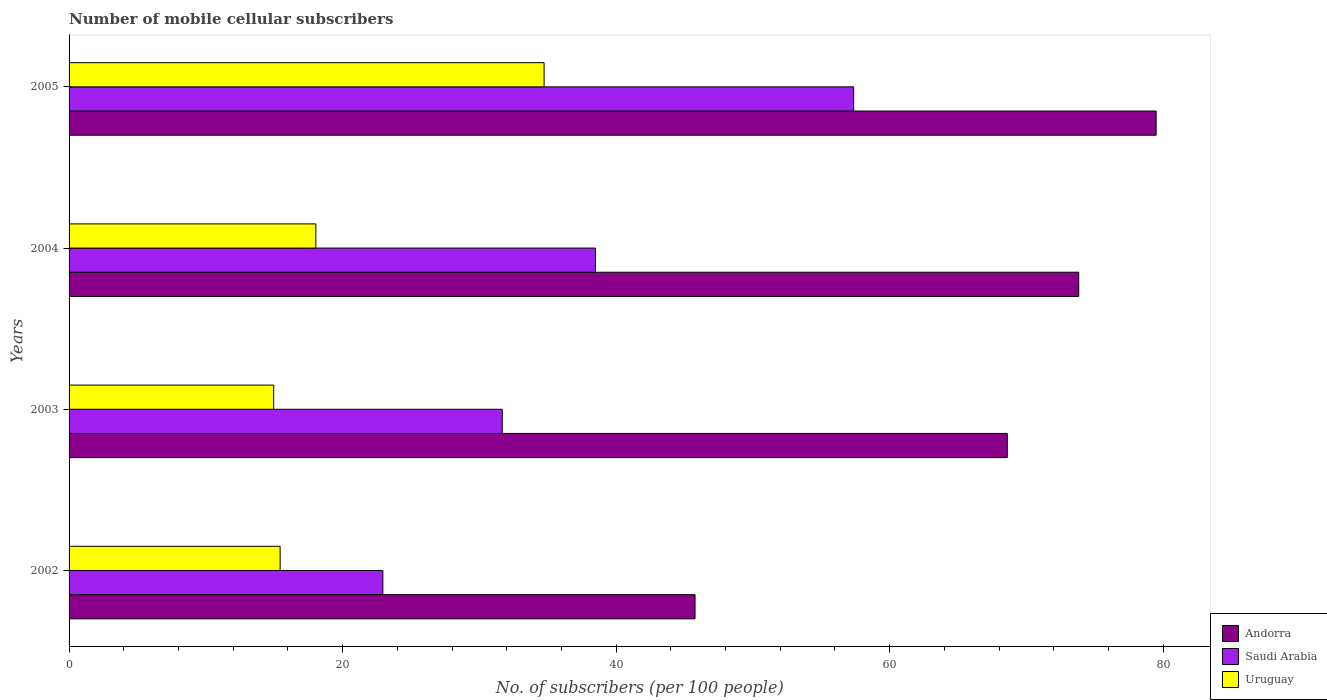How many groups of bars are there?
Ensure brevity in your answer.  4. How many bars are there on the 2nd tick from the top?
Your answer should be compact. 3. What is the label of the 3rd group of bars from the top?
Make the answer very short. 2003. What is the number of mobile cellular subscribers in Andorra in 2004?
Your response must be concise. 73.82. Across all years, what is the maximum number of mobile cellular subscribers in Andorra?
Make the answer very short. 79.48. Across all years, what is the minimum number of mobile cellular subscribers in Andorra?
Provide a succinct answer. 45.77. In which year was the number of mobile cellular subscribers in Uruguay maximum?
Provide a short and direct response. 2005. What is the total number of mobile cellular subscribers in Andorra in the graph?
Offer a terse response. 267.68. What is the difference between the number of mobile cellular subscribers in Uruguay in 2004 and that in 2005?
Your response must be concise. -16.69. What is the difference between the number of mobile cellular subscribers in Saudi Arabia in 2005 and the number of mobile cellular subscribers in Uruguay in 2002?
Offer a terse response. 41.94. What is the average number of mobile cellular subscribers in Andorra per year?
Give a very brief answer. 66.92. In the year 2002, what is the difference between the number of mobile cellular subscribers in Saudi Arabia and number of mobile cellular subscribers in Andorra?
Make the answer very short. -22.83. What is the ratio of the number of mobile cellular subscribers in Uruguay in 2002 to that in 2003?
Offer a very short reply. 1.03. Is the difference between the number of mobile cellular subscribers in Saudi Arabia in 2004 and 2005 greater than the difference between the number of mobile cellular subscribers in Andorra in 2004 and 2005?
Provide a short and direct response. No. What is the difference between the highest and the second highest number of mobile cellular subscribers in Andorra?
Provide a succinct answer. 5.66. What is the difference between the highest and the lowest number of mobile cellular subscribers in Andorra?
Provide a succinct answer. 33.71. Is the sum of the number of mobile cellular subscribers in Uruguay in 2002 and 2003 greater than the maximum number of mobile cellular subscribers in Andorra across all years?
Keep it short and to the point. No. What does the 2nd bar from the top in 2004 represents?
Provide a succinct answer. Saudi Arabia. What does the 2nd bar from the bottom in 2003 represents?
Your answer should be very brief. Saudi Arabia. How many bars are there?
Give a very brief answer. 12. What is the difference between two consecutive major ticks on the X-axis?
Offer a terse response. 20. Does the graph contain grids?
Offer a terse response. No. How are the legend labels stacked?
Make the answer very short. Vertical. What is the title of the graph?
Provide a succinct answer. Number of mobile cellular subscribers. What is the label or title of the X-axis?
Ensure brevity in your answer.  No. of subscribers (per 100 people). What is the No. of subscribers (per 100 people) of Andorra in 2002?
Offer a very short reply. 45.77. What is the No. of subscribers (per 100 people) in Saudi Arabia in 2002?
Provide a succinct answer. 22.95. What is the No. of subscribers (per 100 people) of Uruguay in 2002?
Your answer should be very brief. 15.43. What is the No. of subscribers (per 100 people) in Andorra in 2003?
Provide a short and direct response. 68.6. What is the No. of subscribers (per 100 people) in Saudi Arabia in 2003?
Give a very brief answer. 31.67. What is the No. of subscribers (per 100 people) of Uruguay in 2003?
Give a very brief answer. 14.96. What is the No. of subscribers (per 100 people) of Andorra in 2004?
Your response must be concise. 73.82. What is the No. of subscribers (per 100 people) in Saudi Arabia in 2004?
Offer a very short reply. 38.49. What is the No. of subscribers (per 100 people) of Uruguay in 2004?
Provide a succinct answer. 18.04. What is the No. of subscribers (per 100 people) in Andorra in 2005?
Your answer should be very brief. 79.48. What is the No. of subscribers (per 100 people) of Saudi Arabia in 2005?
Your response must be concise. 57.37. What is the No. of subscribers (per 100 people) of Uruguay in 2005?
Offer a terse response. 34.73. Across all years, what is the maximum No. of subscribers (per 100 people) in Andorra?
Keep it short and to the point. 79.48. Across all years, what is the maximum No. of subscribers (per 100 people) of Saudi Arabia?
Provide a succinct answer. 57.37. Across all years, what is the maximum No. of subscribers (per 100 people) in Uruguay?
Offer a terse response. 34.73. Across all years, what is the minimum No. of subscribers (per 100 people) in Andorra?
Your answer should be compact. 45.77. Across all years, what is the minimum No. of subscribers (per 100 people) of Saudi Arabia?
Provide a succinct answer. 22.95. Across all years, what is the minimum No. of subscribers (per 100 people) of Uruguay?
Your answer should be very brief. 14.96. What is the total No. of subscribers (per 100 people) in Andorra in the graph?
Your answer should be compact. 267.68. What is the total No. of subscribers (per 100 people) in Saudi Arabia in the graph?
Make the answer very short. 150.48. What is the total No. of subscribers (per 100 people) of Uruguay in the graph?
Keep it short and to the point. 83.17. What is the difference between the No. of subscribers (per 100 people) of Andorra in 2002 and that in 2003?
Ensure brevity in your answer.  -22.83. What is the difference between the No. of subscribers (per 100 people) in Saudi Arabia in 2002 and that in 2003?
Your answer should be compact. -8.73. What is the difference between the No. of subscribers (per 100 people) in Uruguay in 2002 and that in 2003?
Your answer should be compact. 0.47. What is the difference between the No. of subscribers (per 100 people) of Andorra in 2002 and that in 2004?
Give a very brief answer. -28.05. What is the difference between the No. of subscribers (per 100 people) of Saudi Arabia in 2002 and that in 2004?
Provide a succinct answer. -15.54. What is the difference between the No. of subscribers (per 100 people) of Uruguay in 2002 and that in 2004?
Give a very brief answer. -2.61. What is the difference between the No. of subscribers (per 100 people) of Andorra in 2002 and that in 2005?
Give a very brief answer. -33.71. What is the difference between the No. of subscribers (per 100 people) in Saudi Arabia in 2002 and that in 2005?
Offer a terse response. -34.42. What is the difference between the No. of subscribers (per 100 people) in Uruguay in 2002 and that in 2005?
Provide a short and direct response. -19.3. What is the difference between the No. of subscribers (per 100 people) in Andorra in 2003 and that in 2004?
Provide a short and direct response. -5.22. What is the difference between the No. of subscribers (per 100 people) in Saudi Arabia in 2003 and that in 2004?
Offer a very short reply. -6.82. What is the difference between the No. of subscribers (per 100 people) of Uruguay in 2003 and that in 2004?
Your answer should be compact. -3.08. What is the difference between the No. of subscribers (per 100 people) of Andorra in 2003 and that in 2005?
Make the answer very short. -10.88. What is the difference between the No. of subscribers (per 100 people) of Saudi Arabia in 2003 and that in 2005?
Your answer should be very brief. -25.69. What is the difference between the No. of subscribers (per 100 people) in Uruguay in 2003 and that in 2005?
Make the answer very short. -19.77. What is the difference between the No. of subscribers (per 100 people) in Andorra in 2004 and that in 2005?
Keep it short and to the point. -5.66. What is the difference between the No. of subscribers (per 100 people) of Saudi Arabia in 2004 and that in 2005?
Your answer should be very brief. -18.88. What is the difference between the No. of subscribers (per 100 people) in Uruguay in 2004 and that in 2005?
Provide a succinct answer. -16.69. What is the difference between the No. of subscribers (per 100 people) of Andorra in 2002 and the No. of subscribers (per 100 people) of Saudi Arabia in 2003?
Provide a succinct answer. 14.1. What is the difference between the No. of subscribers (per 100 people) of Andorra in 2002 and the No. of subscribers (per 100 people) of Uruguay in 2003?
Offer a very short reply. 30.81. What is the difference between the No. of subscribers (per 100 people) in Saudi Arabia in 2002 and the No. of subscribers (per 100 people) in Uruguay in 2003?
Your answer should be very brief. 7.98. What is the difference between the No. of subscribers (per 100 people) of Andorra in 2002 and the No. of subscribers (per 100 people) of Saudi Arabia in 2004?
Provide a succinct answer. 7.28. What is the difference between the No. of subscribers (per 100 people) of Andorra in 2002 and the No. of subscribers (per 100 people) of Uruguay in 2004?
Offer a very short reply. 27.73. What is the difference between the No. of subscribers (per 100 people) in Saudi Arabia in 2002 and the No. of subscribers (per 100 people) in Uruguay in 2004?
Your answer should be very brief. 4.9. What is the difference between the No. of subscribers (per 100 people) in Andorra in 2002 and the No. of subscribers (per 100 people) in Saudi Arabia in 2005?
Your response must be concise. -11.6. What is the difference between the No. of subscribers (per 100 people) of Andorra in 2002 and the No. of subscribers (per 100 people) of Uruguay in 2005?
Keep it short and to the point. 11.04. What is the difference between the No. of subscribers (per 100 people) of Saudi Arabia in 2002 and the No. of subscribers (per 100 people) of Uruguay in 2005?
Make the answer very short. -11.79. What is the difference between the No. of subscribers (per 100 people) in Andorra in 2003 and the No. of subscribers (per 100 people) in Saudi Arabia in 2004?
Make the answer very short. 30.11. What is the difference between the No. of subscribers (per 100 people) of Andorra in 2003 and the No. of subscribers (per 100 people) of Uruguay in 2004?
Provide a succinct answer. 50.56. What is the difference between the No. of subscribers (per 100 people) in Saudi Arabia in 2003 and the No. of subscribers (per 100 people) in Uruguay in 2004?
Your answer should be compact. 13.63. What is the difference between the No. of subscribers (per 100 people) of Andorra in 2003 and the No. of subscribers (per 100 people) of Saudi Arabia in 2005?
Ensure brevity in your answer.  11.23. What is the difference between the No. of subscribers (per 100 people) in Andorra in 2003 and the No. of subscribers (per 100 people) in Uruguay in 2005?
Your answer should be compact. 33.87. What is the difference between the No. of subscribers (per 100 people) of Saudi Arabia in 2003 and the No. of subscribers (per 100 people) of Uruguay in 2005?
Your answer should be very brief. -3.06. What is the difference between the No. of subscribers (per 100 people) in Andorra in 2004 and the No. of subscribers (per 100 people) in Saudi Arabia in 2005?
Give a very brief answer. 16.46. What is the difference between the No. of subscribers (per 100 people) in Andorra in 2004 and the No. of subscribers (per 100 people) in Uruguay in 2005?
Your answer should be compact. 39.09. What is the difference between the No. of subscribers (per 100 people) of Saudi Arabia in 2004 and the No. of subscribers (per 100 people) of Uruguay in 2005?
Your answer should be very brief. 3.76. What is the average No. of subscribers (per 100 people) of Andorra per year?
Provide a short and direct response. 66.92. What is the average No. of subscribers (per 100 people) of Saudi Arabia per year?
Offer a very short reply. 37.62. What is the average No. of subscribers (per 100 people) of Uruguay per year?
Ensure brevity in your answer.  20.79. In the year 2002, what is the difference between the No. of subscribers (per 100 people) of Andorra and No. of subscribers (per 100 people) of Saudi Arabia?
Give a very brief answer. 22.83. In the year 2002, what is the difference between the No. of subscribers (per 100 people) of Andorra and No. of subscribers (per 100 people) of Uruguay?
Offer a very short reply. 30.34. In the year 2002, what is the difference between the No. of subscribers (per 100 people) in Saudi Arabia and No. of subscribers (per 100 people) in Uruguay?
Provide a short and direct response. 7.51. In the year 2003, what is the difference between the No. of subscribers (per 100 people) in Andorra and No. of subscribers (per 100 people) in Saudi Arabia?
Your answer should be compact. 36.93. In the year 2003, what is the difference between the No. of subscribers (per 100 people) of Andorra and No. of subscribers (per 100 people) of Uruguay?
Make the answer very short. 53.64. In the year 2003, what is the difference between the No. of subscribers (per 100 people) of Saudi Arabia and No. of subscribers (per 100 people) of Uruguay?
Provide a short and direct response. 16.71. In the year 2004, what is the difference between the No. of subscribers (per 100 people) of Andorra and No. of subscribers (per 100 people) of Saudi Arabia?
Keep it short and to the point. 35.33. In the year 2004, what is the difference between the No. of subscribers (per 100 people) in Andorra and No. of subscribers (per 100 people) in Uruguay?
Make the answer very short. 55.78. In the year 2004, what is the difference between the No. of subscribers (per 100 people) of Saudi Arabia and No. of subscribers (per 100 people) of Uruguay?
Keep it short and to the point. 20.45. In the year 2005, what is the difference between the No. of subscribers (per 100 people) in Andorra and No. of subscribers (per 100 people) in Saudi Arabia?
Your response must be concise. 22.12. In the year 2005, what is the difference between the No. of subscribers (per 100 people) of Andorra and No. of subscribers (per 100 people) of Uruguay?
Keep it short and to the point. 44.75. In the year 2005, what is the difference between the No. of subscribers (per 100 people) in Saudi Arabia and No. of subscribers (per 100 people) in Uruguay?
Keep it short and to the point. 22.64. What is the ratio of the No. of subscribers (per 100 people) of Andorra in 2002 to that in 2003?
Ensure brevity in your answer.  0.67. What is the ratio of the No. of subscribers (per 100 people) in Saudi Arabia in 2002 to that in 2003?
Provide a short and direct response. 0.72. What is the ratio of the No. of subscribers (per 100 people) in Uruguay in 2002 to that in 2003?
Give a very brief answer. 1.03. What is the ratio of the No. of subscribers (per 100 people) of Andorra in 2002 to that in 2004?
Provide a succinct answer. 0.62. What is the ratio of the No. of subscribers (per 100 people) in Saudi Arabia in 2002 to that in 2004?
Ensure brevity in your answer.  0.6. What is the ratio of the No. of subscribers (per 100 people) of Uruguay in 2002 to that in 2004?
Make the answer very short. 0.86. What is the ratio of the No. of subscribers (per 100 people) in Andorra in 2002 to that in 2005?
Your answer should be compact. 0.58. What is the ratio of the No. of subscribers (per 100 people) of Uruguay in 2002 to that in 2005?
Ensure brevity in your answer.  0.44. What is the ratio of the No. of subscribers (per 100 people) of Andorra in 2003 to that in 2004?
Make the answer very short. 0.93. What is the ratio of the No. of subscribers (per 100 people) of Saudi Arabia in 2003 to that in 2004?
Offer a terse response. 0.82. What is the ratio of the No. of subscribers (per 100 people) in Uruguay in 2003 to that in 2004?
Offer a terse response. 0.83. What is the ratio of the No. of subscribers (per 100 people) of Andorra in 2003 to that in 2005?
Provide a short and direct response. 0.86. What is the ratio of the No. of subscribers (per 100 people) of Saudi Arabia in 2003 to that in 2005?
Your answer should be compact. 0.55. What is the ratio of the No. of subscribers (per 100 people) of Uruguay in 2003 to that in 2005?
Keep it short and to the point. 0.43. What is the ratio of the No. of subscribers (per 100 people) in Andorra in 2004 to that in 2005?
Provide a succinct answer. 0.93. What is the ratio of the No. of subscribers (per 100 people) in Saudi Arabia in 2004 to that in 2005?
Keep it short and to the point. 0.67. What is the ratio of the No. of subscribers (per 100 people) in Uruguay in 2004 to that in 2005?
Offer a very short reply. 0.52. What is the difference between the highest and the second highest No. of subscribers (per 100 people) in Andorra?
Offer a very short reply. 5.66. What is the difference between the highest and the second highest No. of subscribers (per 100 people) in Saudi Arabia?
Provide a succinct answer. 18.88. What is the difference between the highest and the second highest No. of subscribers (per 100 people) in Uruguay?
Keep it short and to the point. 16.69. What is the difference between the highest and the lowest No. of subscribers (per 100 people) of Andorra?
Ensure brevity in your answer.  33.71. What is the difference between the highest and the lowest No. of subscribers (per 100 people) in Saudi Arabia?
Keep it short and to the point. 34.42. What is the difference between the highest and the lowest No. of subscribers (per 100 people) in Uruguay?
Offer a terse response. 19.77. 